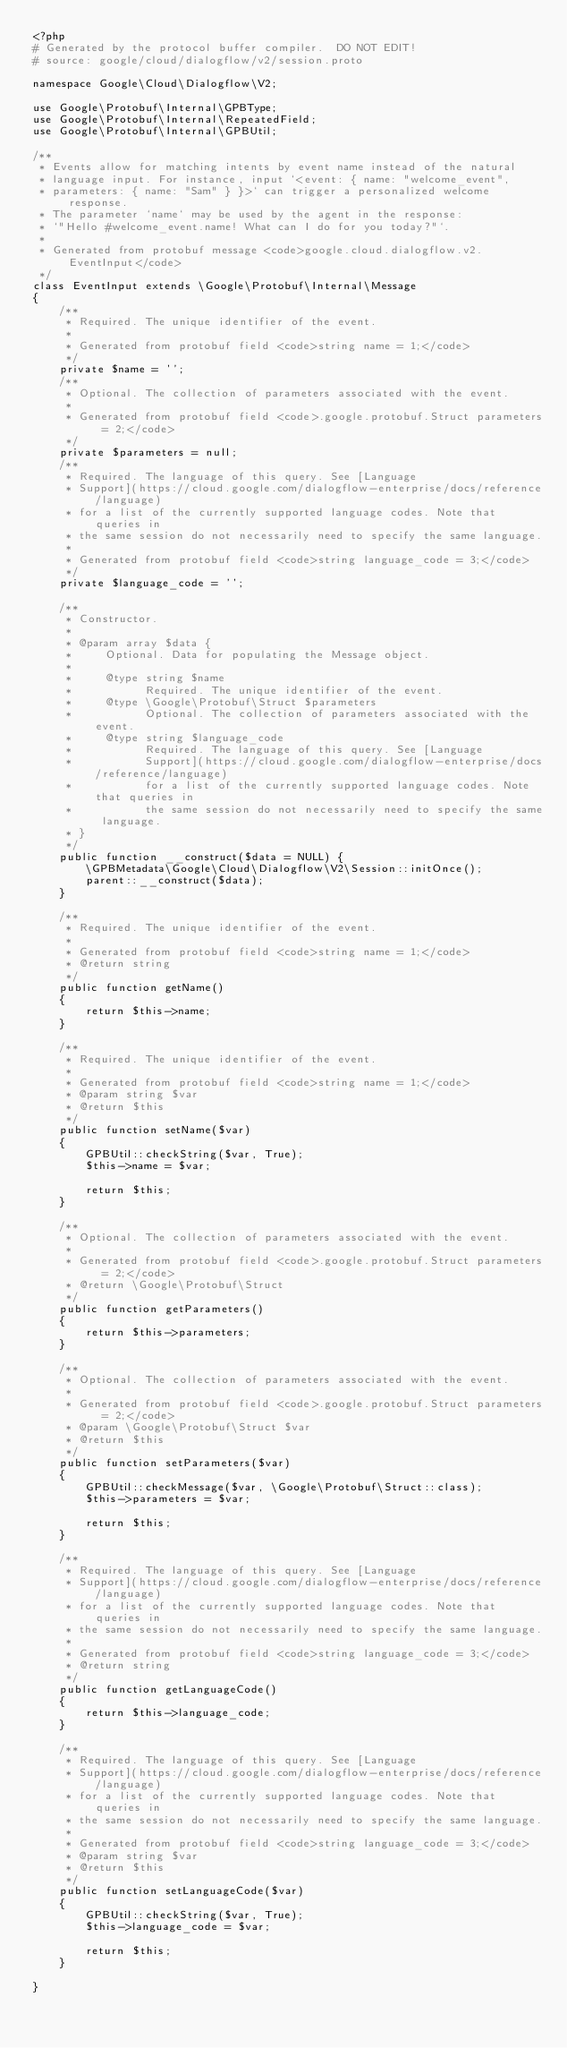Convert code to text. <code><loc_0><loc_0><loc_500><loc_500><_PHP_><?php
# Generated by the protocol buffer compiler.  DO NOT EDIT!
# source: google/cloud/dialogflow/v2/session.proto

namespace Google\Cloud\Dialogflow\V2;

use Google\Protobuf\Internal\GPBType;
use Google\Protobuf\Internal\RepeatedField;
use Google\Protobuf\Internal\GPBUtil;

/**
 * Events allow for matching intents by event name instead of the natural
 * language input. For instance, input `<event: { name: "welcome_event",
 * parameters: { name: "Sam" } }>` can trigger a personalized welcome response.
 * The parameter `name` may be used by the agent in the response:
 * `"Hello #welcome_event.name! What can I do for you today?"`.
 *
 * Generated from protobuf message <code>google.cloud.dialogflow.v2.EventInput</code>
 */
class EventInput extends \Google\Protobuf\Internal\Message
{
    /**
     * Required. The unique identifier of the event.
     *
     * Generated from protobuf field <code>string name = 1;</code>
     */
    private $name = '';
    /**
     * Optional. The collection of parameters associated with the event.
     *
     * Generated from protobuf field <code>.google.protobuf.Struct parameters = 2;</code>
     */
    private $parameters = null;
    /**
     * Required. The language of this query. See [Language
     * Support](https://cloud.google.com/dialogflow-enterprise/docs/reference/language)
     * for a list of the currently supported language codes. Note that queries in
     * the same session do not necessarily need to specify the same language.
     *
     * Generated from protobuf field <code>string language_code = 3;</code>
     */
    private $language_code = '';

    /**
     * Constructor.
     *
     * @param array $data {
     *     Optional. Data for populating the Message object.
     *
     *     @type string $name
     *           Required. The unique identifier of the event.
     *     @type \Google\Protobuf\Struct $parameters
     *           Optional. The collection of parameters associated with the event.
     *     @type string $language_code
     *           Required. The language of this query. See [Language
     *           Support](https://cloud.google.com/dialogflow-enterprise/docs/reference/language)
     *           for a list of the currently supported language codes. Note that queries in
     *           the same session do not necessarily need to specify the same language.
     * }
     */
    public function __construct($data = NULL) {
        \GPBMetadata\Google\Cloud\Dialogflow\V2\Session::initOnce();
        parent::__construct($data);
    }

    /**
     * Required. The unique identifier of the event.
     *
     * Generated from protobuf field <code>string name = 1;</code>
     * @return string
     */
    public function getName()
    {
        return $this->name;
    }

    /**
     * Required. The unique identifier of the event.
     *
     * Generated from protobuf field <code>string name = 1;</code>
     * @param string $var
     * @return $this
     */
    public function setName($var)
    {
        GPBUtil::checkString($var, True);
        $this->name = $var;

        return $this;
    }

    /**
     * Optional. The collection of parameters associated with the event.
     *
     * Generated from protobuf field <code>.google.protobuf.Struct parameters = 2;</code>
     * @return \Google\Protobuf\Struct
     */
    public function getParameters()
    {
        return $this->parameters;
    }

    /**
     * Optional. The collection of parameters associated with the event.
     *
     * Generated from protobuf field <code>.google.protobuf.Struct parameters = 2;</code>
     * @param \Google\Protobuf\Struct $var
     * @return $this
     */
    public function setParameters($var)
    {
        GPBUtil::checkMessage($var, \Google\Protobuf\Struct::class);
        $this->parameters = $var;

        return $this;
    }

    /**
     * Required. The language of this query. See [Language
     * Support](https://cloud.google.com/dialogflow-enterprise/docs/reference/language)
     * for a list of the currently supported language codes. Note that queries in
     * the same session do not necessarily need to specify the same language.
     *
     * Generated from protobuf field <code>string language_code = 3;</code>
     * @return string
     */
    public function getLanguageCode()
    {
        return $this->language_code;
    }

    /**
     * Required. The language of this query. See [Language
     * Support](https://cloud.google.com/dialogflow-enterprise/docs/reference/language)
     * for a list of the currently supported language codes. Note that queries in
     * the same session do not necessarily need to specify the same language.
     *
     * Generated from protobuf field <code>string language_code = 3;</code>
     * @param string $var
     * @return $this
     */
    public function setLanguageCode($var)
    {
        GPBUtil::checkString($var, True);
        $this->language_code = $var;

        return $this;
    }

}

</code> 